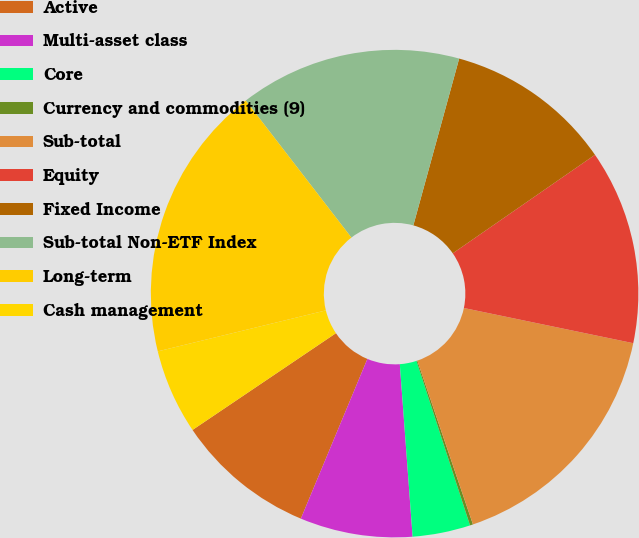<chart> <loc_0><loc_0><loc_500><loc_500><pie_chart><fcel>Active<fcel>Multi-asset class<fcel>Core<fcel>Currency and commodities (9)<fcel>Sub-total<fcel>Equity<fcel>Fixed Income<fcel>Sub-total Non-ETF Index<fcel>Long-term<fcel>Cash management<nl><fcel>9.27%<fcel>7.46%<fcel>3.83%<fcel>0.2%<fcel>16.53%<fcel>12.9%<fcel>11.09%<fcel>14.72%<fcel>18.35%<fcel>5.64%<nl></chart> 